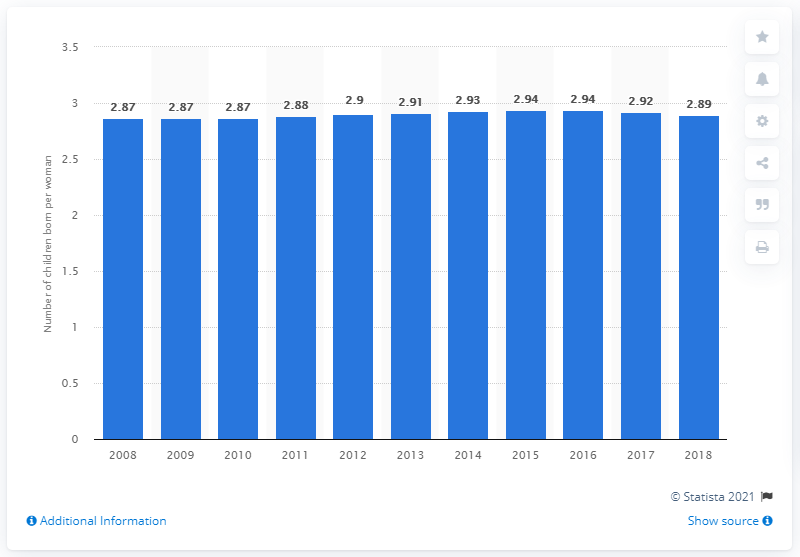Point out several critical features in this image. The fertility rate in Oman in 2018 was 2.89. 